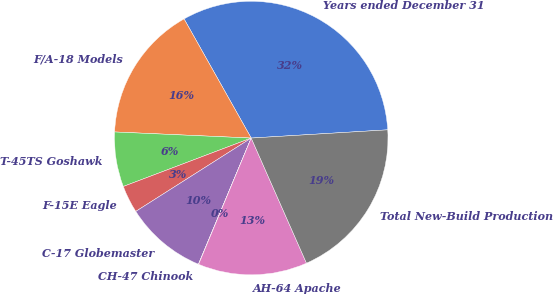<chart> <loc_0><loc_0><loc_500><loc_500><pie_chart><fcel>Years ended December 31<fcel>F/A-18 Models<fcel>T-45TS Goshawk<fcel>F-15E Eagle<fcel>C-17 Globemaster<fcel>CH-47 Chinook<fcel>AH-64 Apache<fcel>Total New-Build Production<nl><fcel>32.21%<fcel>16.12%<fcel>6.47%<fcel>3.25%<fcel>9.68%<fcel>0.03%<fcel>12.9%<fcel>19.34%<nl></chart> 